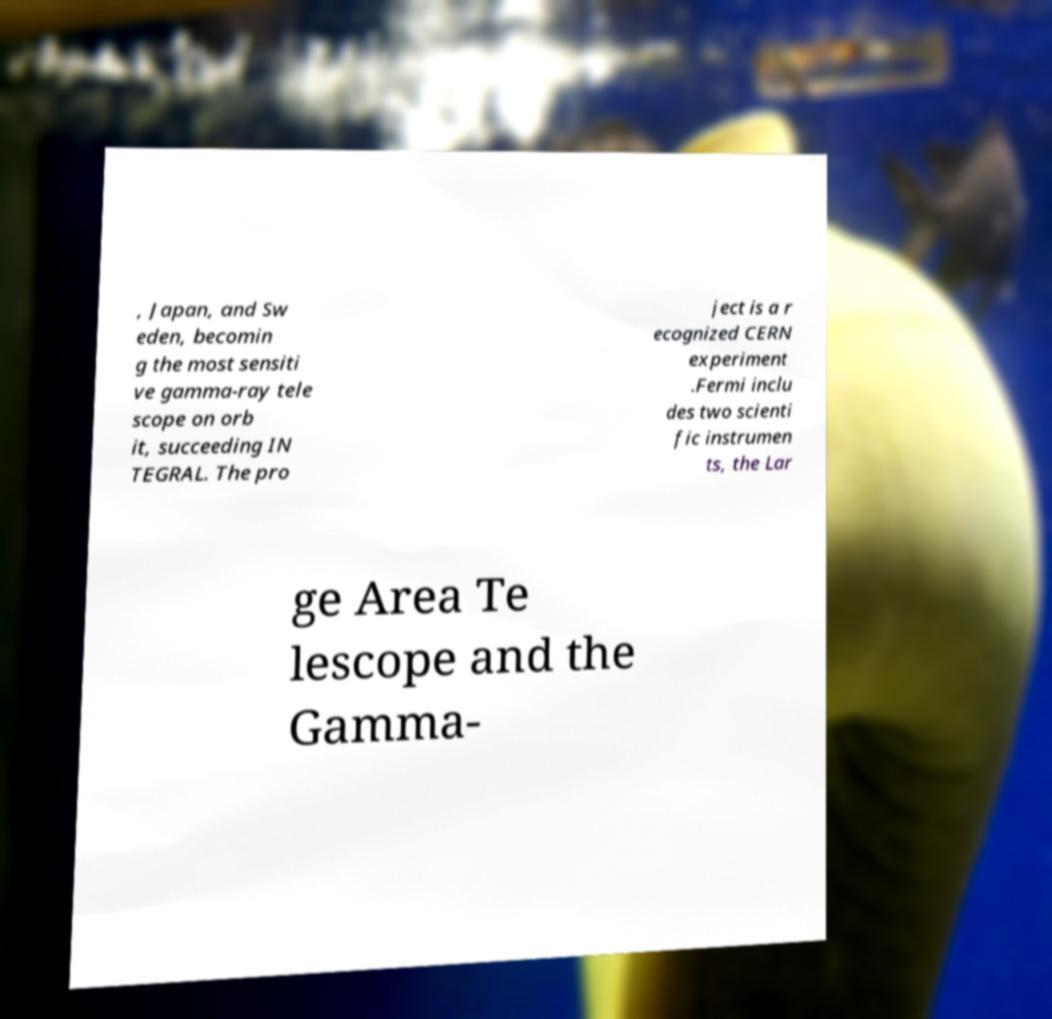Could you assist in decoding the text presented in this image and type it out clearly? , Japan, and Sw eden, becomin g the most sensiti ve gamma-ray tele scope on orb it, succeeding IN TEGRAL. The pro ject is a r ecognized CERN experiment .Fermi inclu des two scienti fic instrumen ts, the Lar ge Area Te lescope and the Gamma- 